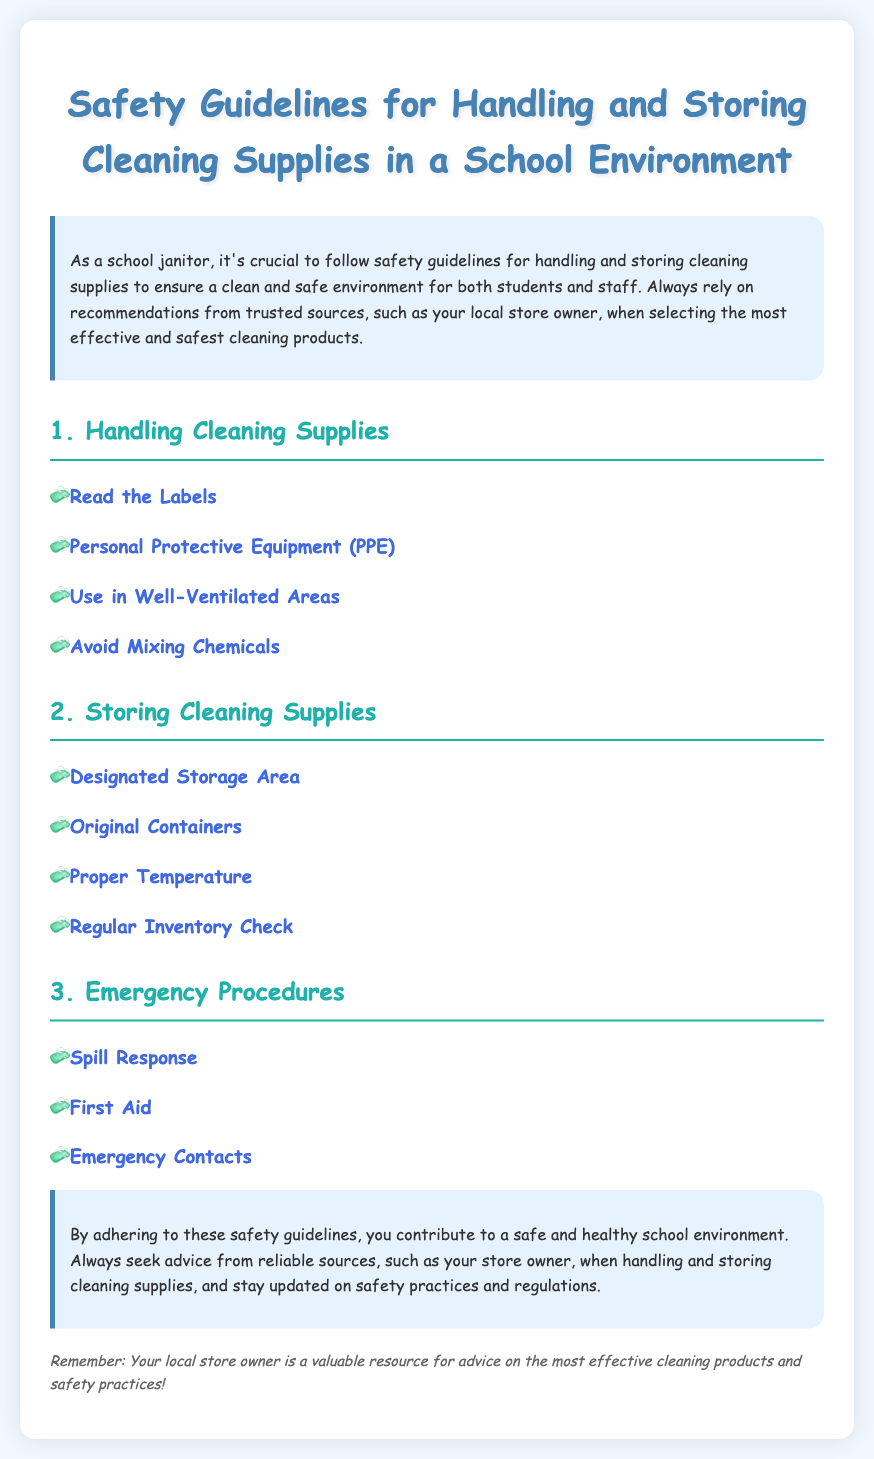What is the title of the document? The title is clearly indicated at the top of the document.
Answer: Safety Guidelines for Handling and Storing Cleaning Supplies in a School Environment What is emphasized as a valuable resource for advice? The document mentions a specific party that provides trusted advice.
Answer: Your local store owner How many main sections are in the document? The sections are numbered and listed for clarity.
Answer: 3 What is one example of Personal Protective Equipment (PPE)? The document highlights the need for PPE under handling guidelines.
Answer: Not provided (the document doesn't list specifics) What should be done to avoid mixing chemicals? This is mentioned in the guidelines under handling.
Answer: Avoid Mixing Chemicals What is a key procedure in case of an emergency? The document lists several emergency procedures that should be known.
Answer: Spill Response Where should cleaning supplies be stored? The document specifies the type of area designated for storage.
Answer: Designated Storage Area What is important to regularly check for cleaning supplies? The document mentions the importance of inventory in the storage section.
Answer: Regular Inventory Check What is noted about the containers for cleaning supplies? The document advises specifics regarding the original state of containers.
Answer: Original Containers 